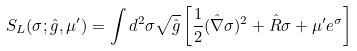<formula> <loc_0><loc_0><loc_500><loc_500>S _ { L } ( \sigma ; \hat { g } , \mu ^ { \prime } ) = \int d ^ { 2 } \sigma \sqrt { \hat { g } } \left [ \frac { 1 } { 2 } ( \hat { \nabla } \sigma ) ^ { 2 } + \hat { R } \sigma + \mu ^ { \prime } e ^ { \sigma } \right ]</formula> 